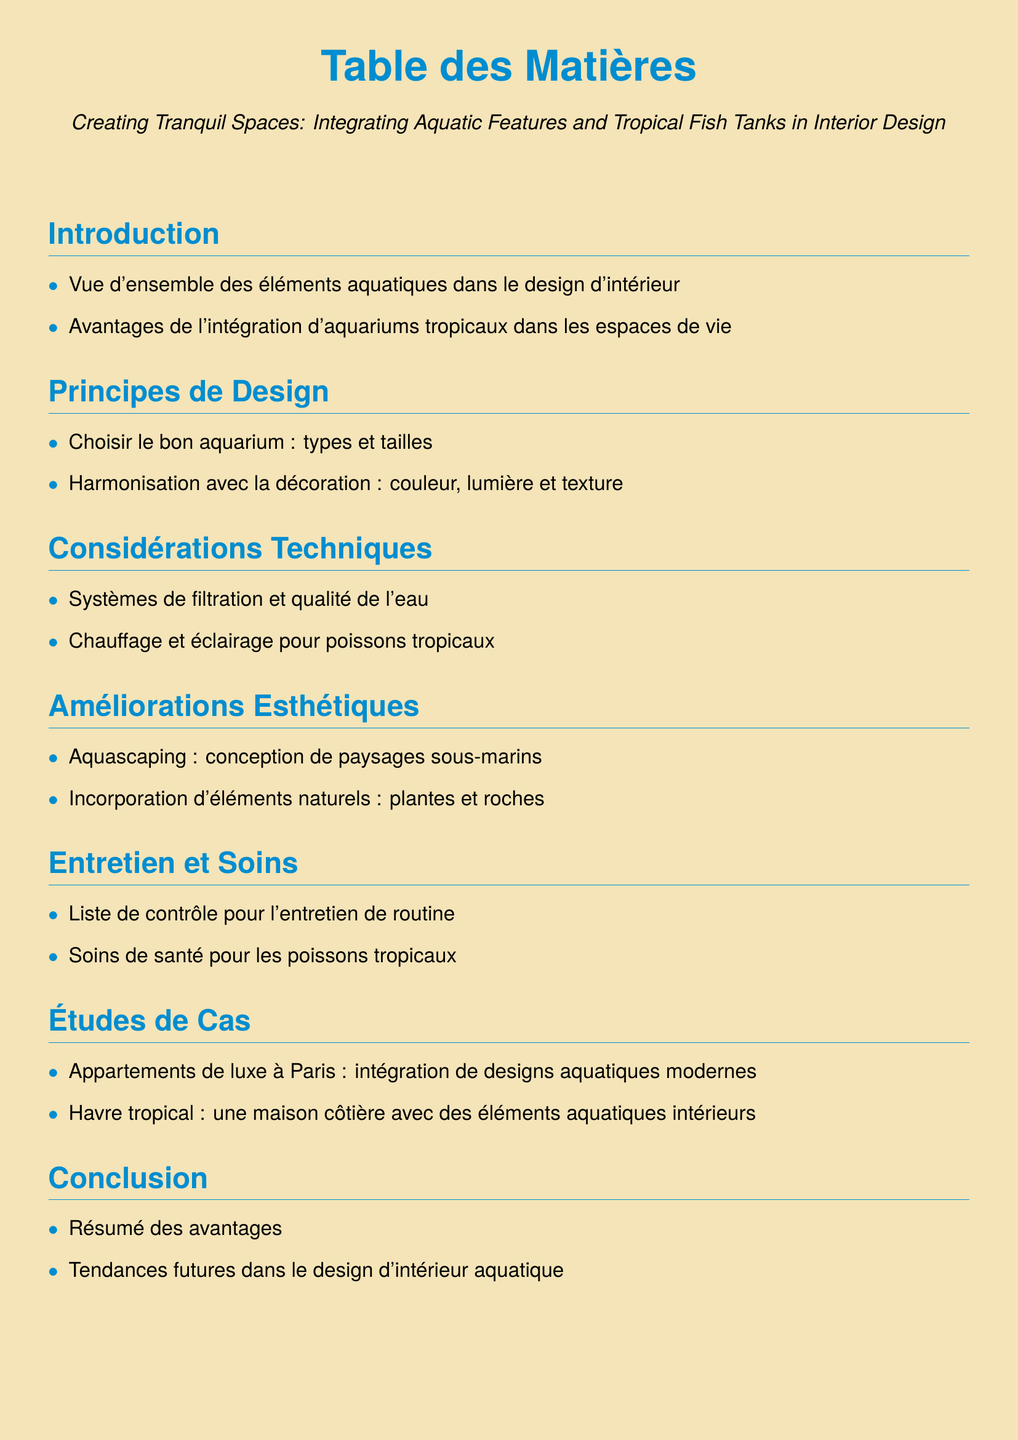What is the title of the document? The title of the document is the main heading that describes its content, which can be found at the beginning.
Answer: Creating Tranquil Spaces: Integrating Aquatic Features and Tropical Fish Tanks in Interior Design How many sections are in the document? The document contains multiple sections that outline different parts of the content.
Answer: 7 What is the main color used in the document? The main color used for headings in the document, as indicated by the color definitions, is used prominently.
Answer: tropicalblue What is one of the advantages of integrating tropical fish tanks? The document provides a brief overview of benefits which can be found in the introduction section.
Answer: Avantages de l'intégration d'aquariums tropicaux dans les espaces de vie What does 'aquascaping' refer to? The term is defined in the sections about aesthetic improvements, specifically discussing its role in aquatic design.
Answer: Conception de paysages sous-marins What is included in the maintenance checklist? A section focuses on care tasks for maintaining tropical fish tanks, which provides guidance on upkeep tasks.
Answer: Liste de contrôle pour l'entretien de routine Which city is mentioned in the case studies? The case studies section details specific locations where aquatic features have been integrated into design.
Answer: Paris What are two technical considerations mentioned? The technical considerations section outlines essential elements necessary for maintaining an aquarium environment.
Answer: Systèmes de filtration et qualité de l'eau; Chauffage et éclairage pour poissons tropicaux What trend is discussed in the conclusion? The conclusion section summarizes themes and anticipates future directions for the incorporation of aquatic designs.
Answer: Tendances futures dans le design d'intérieur aquatique 